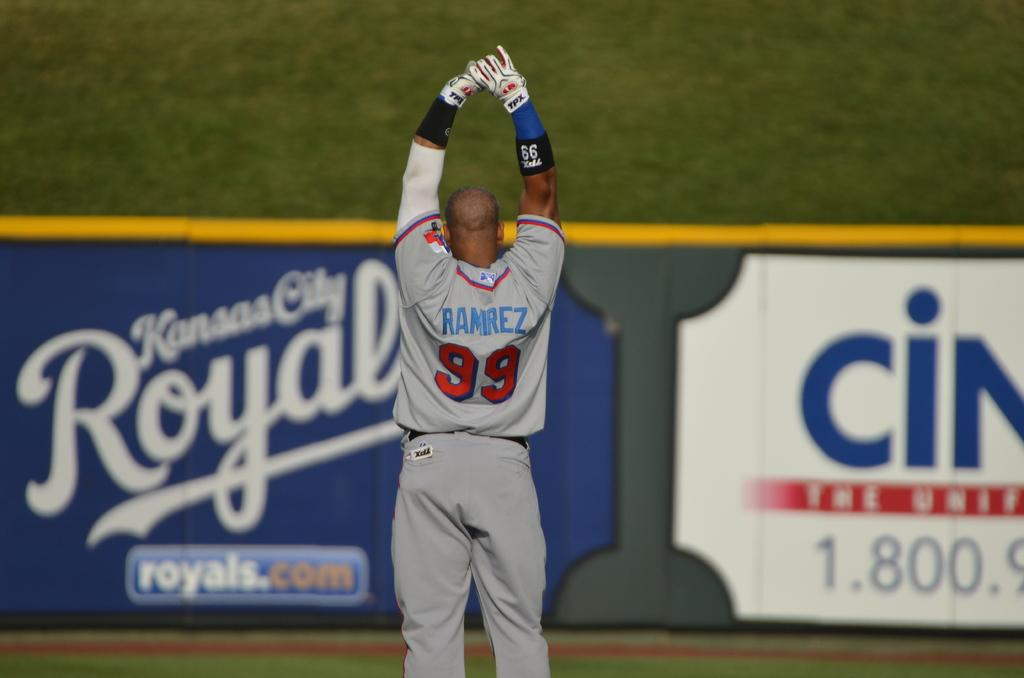Provide a one-sentence caption for the provided image. an image of a baseball player named Ramirez with the number 99, standing in a baseball field with his arms up. 